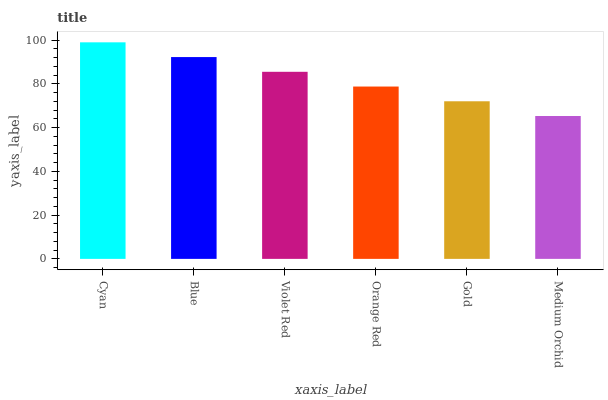Is Blue the minimum?
Answer yes or no. No. Is Blue the maximum?
Answer yes or no. No. Is Cyan greater than Blue?
Answer yes or no. Yes. Is Blue less than Cyan?
Answer yes or no. Yes. Is Blue greater than Cyan?
Answer yes or no. No. Is Cyan less than Blue?
Answer yes or no. No. Is Violet Red the high median?
Answer yes or no. Yes. Is Orange Red the low median?
Answer yes or no. Yes. Is Cyan the high median?
Answer yes or no. No. Is Medium Orchid the low median?
Answer yes or no. No. 